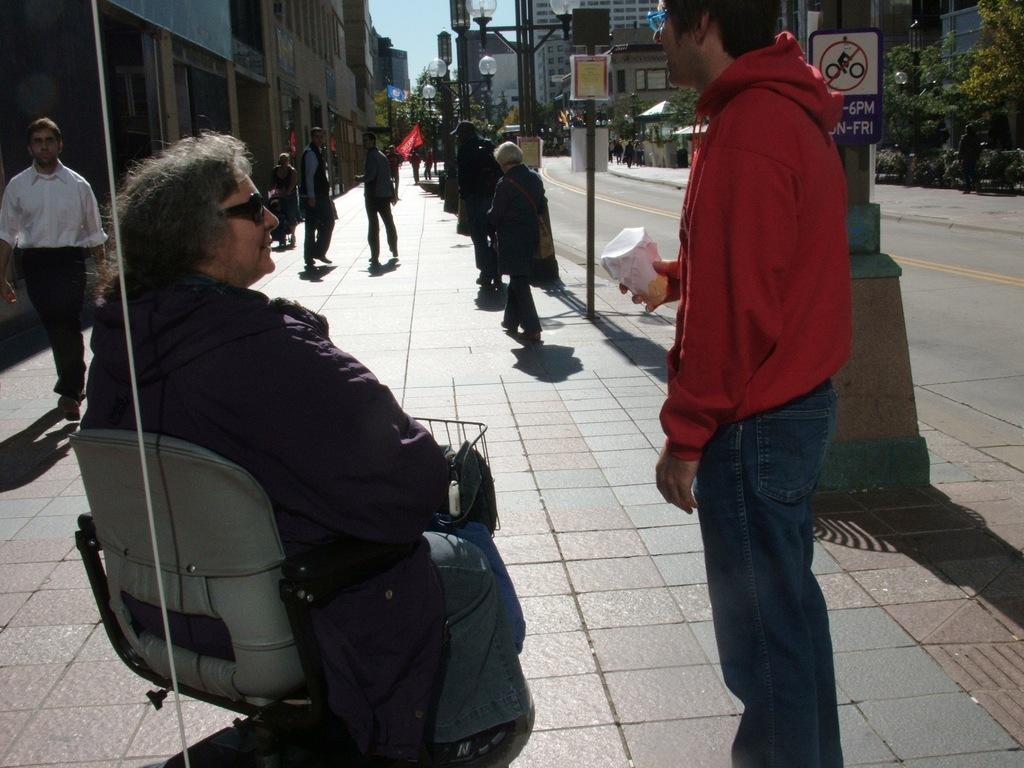Can you describe this image briefly? This is an outside view. Hear I can see a person wearing a jacket, sitting on the chair and looking at the man who is standing in the front. This man is wearing a red color jacket, jeans, holding a glass in the hand. In the background, I can see few people are walking on the footpath. On the right side there is a road. On both sides of the road I can see few poles, trees and buildings. On the top of the image I can see the sky. 